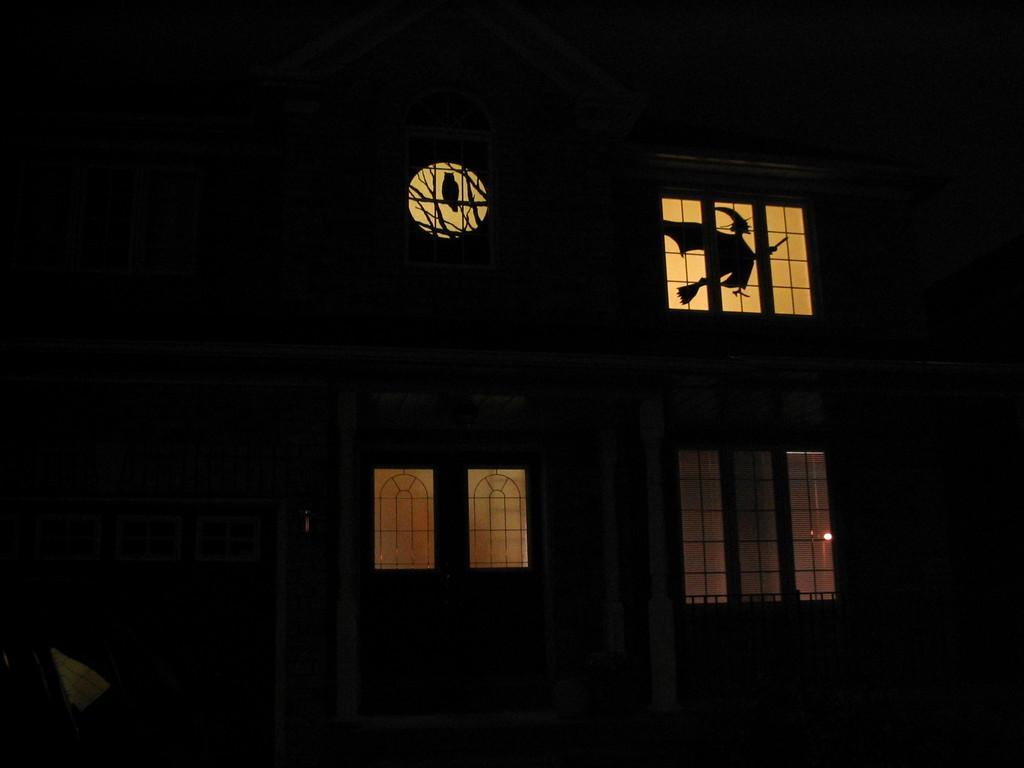Could you give a brief overview of what you see in this image? This picture is dark, in this picture we can see building and windows. 